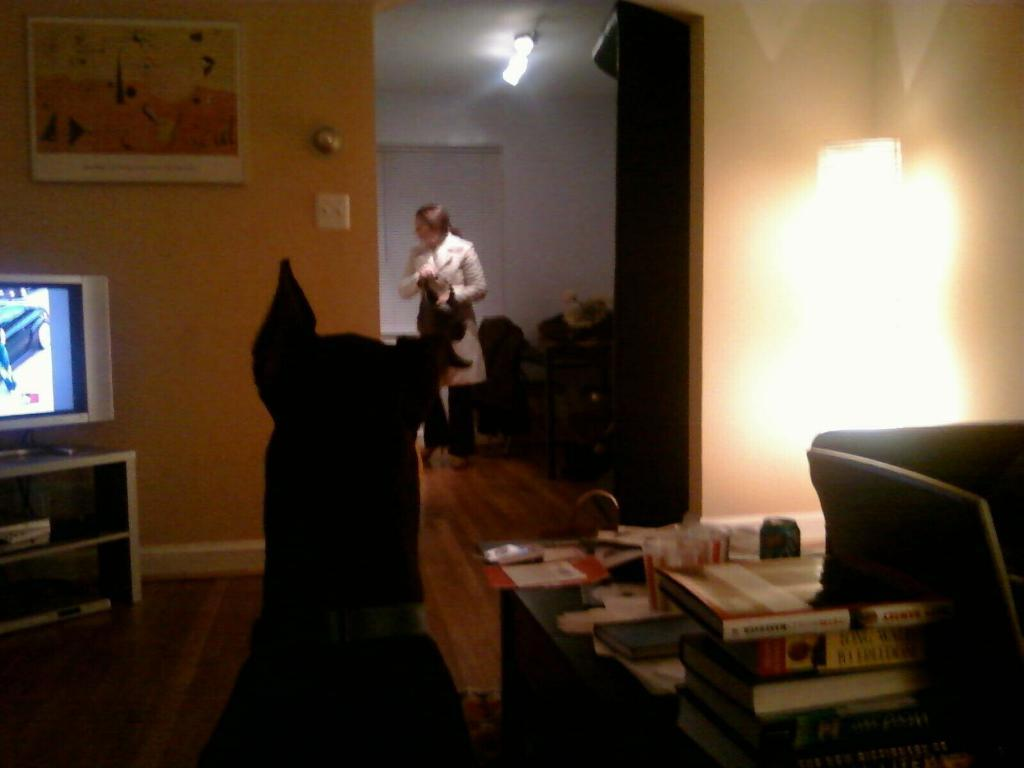What type of animal is present in the image? There is a dog in the image. What objects can be seen on the desk in the image? There are books on a desk in the image. What electronic device is visible in the image? There is a television in the image. Who is present in the image? There is a woman in the image. Can you see any sidewalks in the image? There is no sidewalk present in the image. What type of match is being used by the woman in the image? There is no match present in the image. 